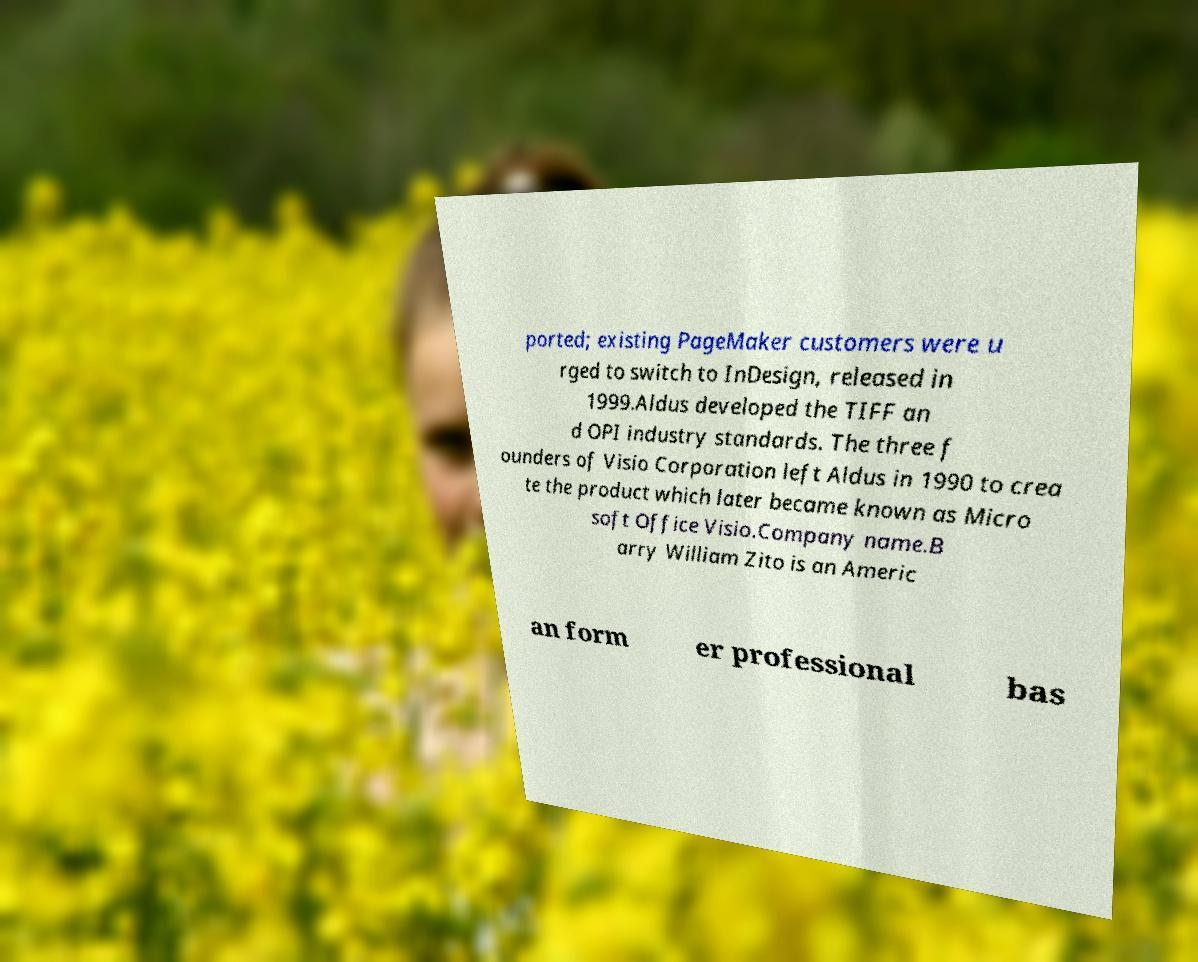Could you assist in decoding the text presented in this image and type it out clearly? ported; existing PageMaker customers were u rged to switch to InDesign, released in 1999.Aldus developed the TIFF an d OPI industry standards. The three f ounders of Visio Corporation left Aldus in 1990 to crea te the product which later became known as Micro soft Office Visio.Company name.B arry William Zito is an Americ an form er professional bas 